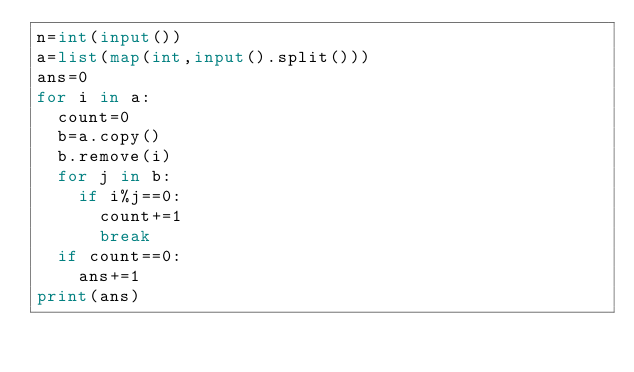<code> <loc_0><loc_0><loc_500><loc_500><_Python_>n=int(input())
a=list(map(int,input().split()))
ans=0
for i in a:
	count=0
	b=a.copy()
	b.remove(i)
	for j in b:
		if i%j==0:
			count+=1
			break
	if count==0:
		ans+=1
print(ans)</code> 